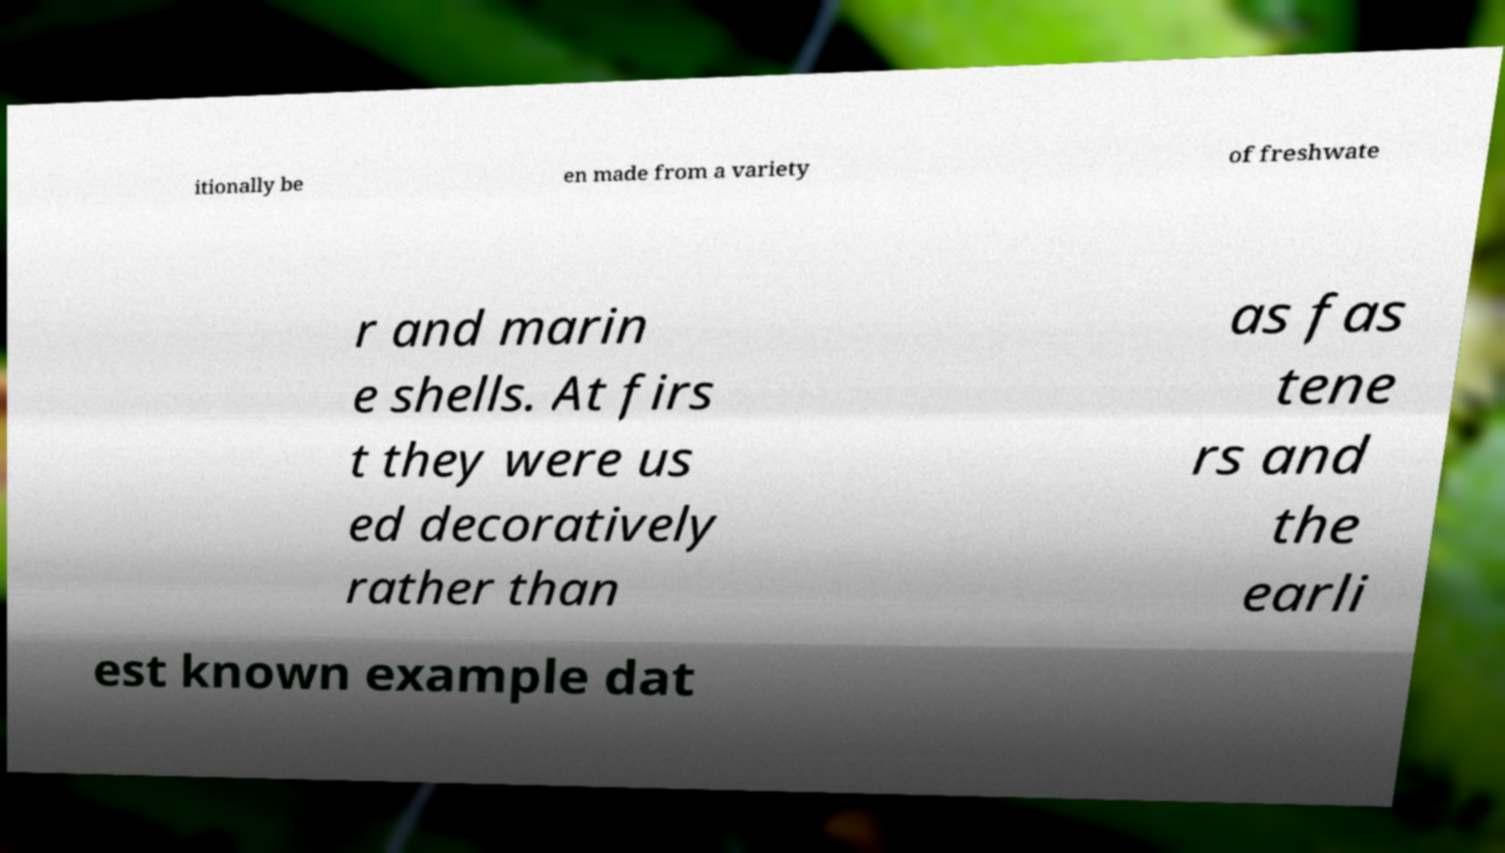Please identify and transcribe the text found in this image. itionally be en made from a variety of freshwate r and marin e shells. At firs t they were us ed decoratively rather than as fas tene rs and the earli est known example dat 